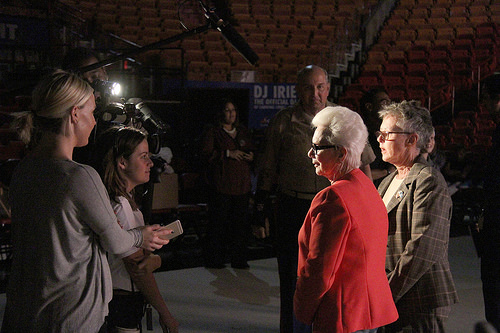<image>
Is there a microphone behind the person? Yes. From this viewpoint, the microphone is positioned behind the person, with the person partially or fully occluding the microphone. 